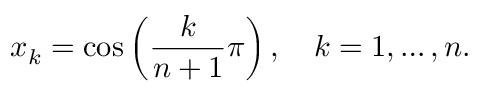Convert formula to latex. <formula><loc_0><loc_0><loc_500><loc_500>x _ { k } = \cos \left ( { \frac { k } { n + 1 } } \pi \right ) , \quad k = 1 , \dots , n .</formula> 